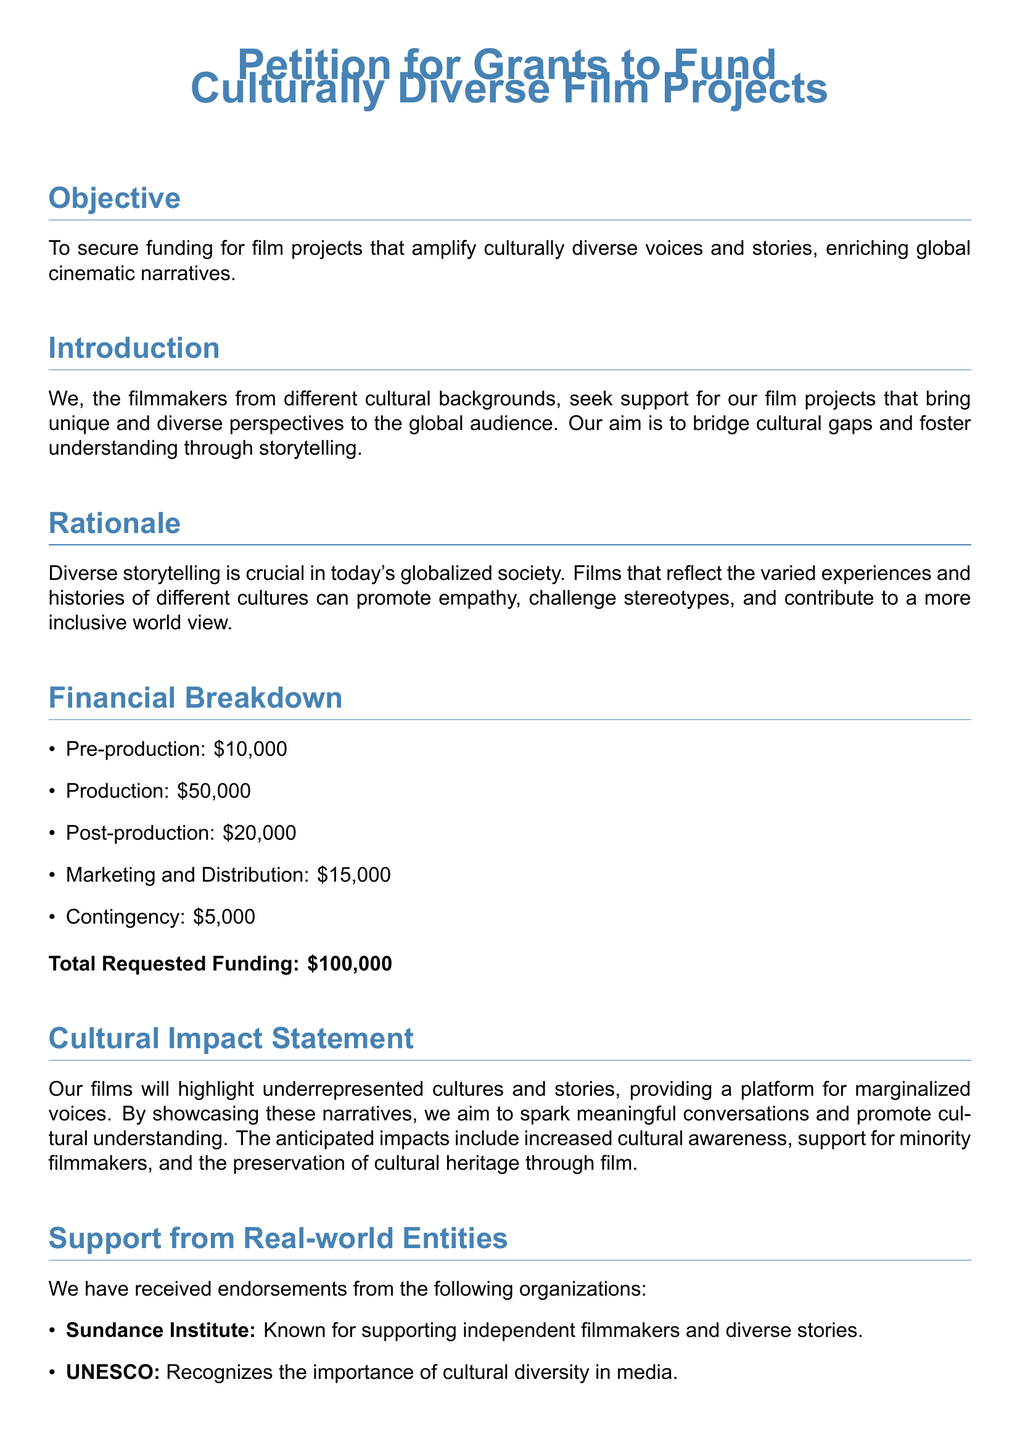What is the total requested funding? The total requested funding is clearly stated in the financial breakdown section.
Answer: \$100,000 What is the pre-production budget? The pre-production budget is specified in the financial breakdown section of the document.
Answer: \$10,000 Which organization is known for supporting independent filmmakers? This question refers to the endorsements section of the document.
Answer: Sundance Institute What is the main objective of this petition? The objective is outlined at the beginning of the document, emphasizing the purpose of the funding.
Answer: To secure funding for film projects that amplify culturally diverse voices and stories What impact do the filmmakers aim to achieve? The cultural impact statement summarizes the anticipated outcomes of the film projects.
Answer: Increased cultural awareness What is the contingency budget amount? The amount allocated for contingency is mentioned in the financial breakdown section.
Answer: \$5,000 Which foundation provides grants for social justice and cultural projects? The organizations listed in the endorsements section provide support for various causes.
Answer: The Ford Foundation What is the goal of highlighting underrepresented cultures? The rationale discusses the intent behind bringing diverse stories to the forefront.
Answer: To promote empathy, challenge stereotypes, and contribute to a more inclusive worldview 